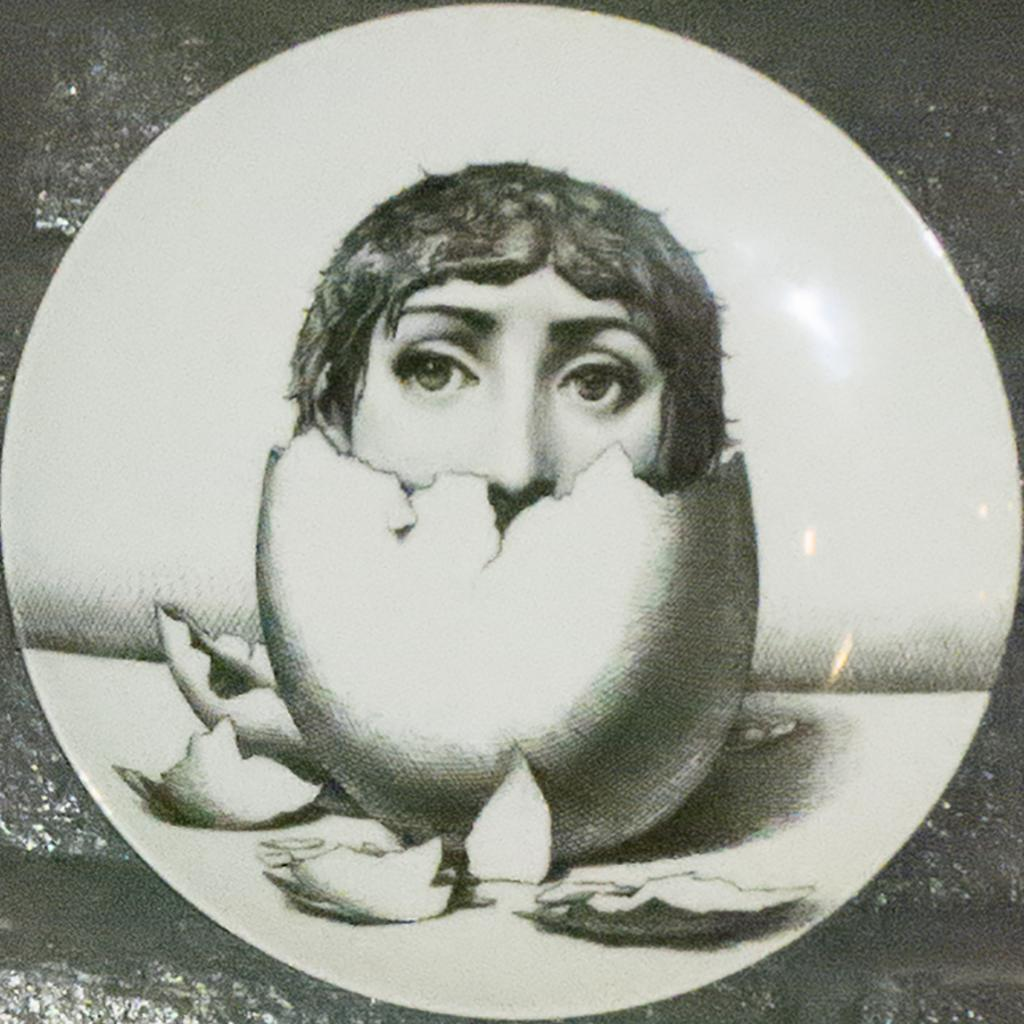What object is present on the table in the image? There is a plate on the table in the image. What is the plate is holding or displaying? The plate has a design of a person's face on the eggshells in the center of the plate. Can you hear the person's voice coming from the plate in the image? There is no voice or sound coming from the plate in the image; it is a static design on the eggshells. 